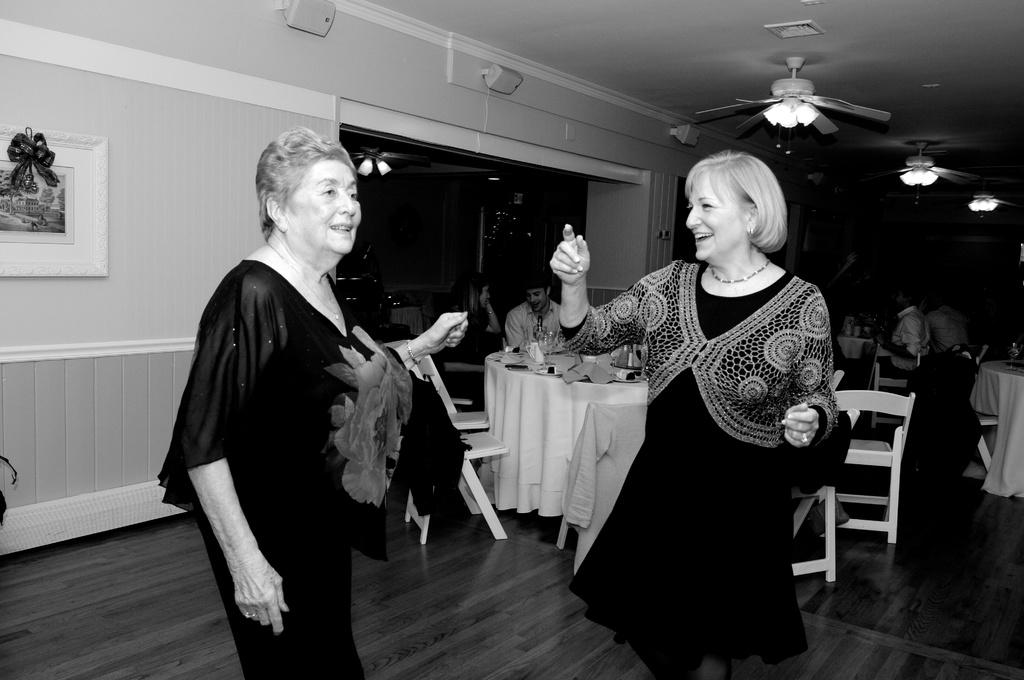What are the two women in the image doing? The two women in the image are dancing. What are the other people in the image doing? The other people in the image are sitting on chairs. Can you describe the presence of any furniture in the image? Yes, there is at least one table in the image. What type of creature is pulling the carriage in the image? There is no carriage present in the image, so it is not possible to answer that question. 